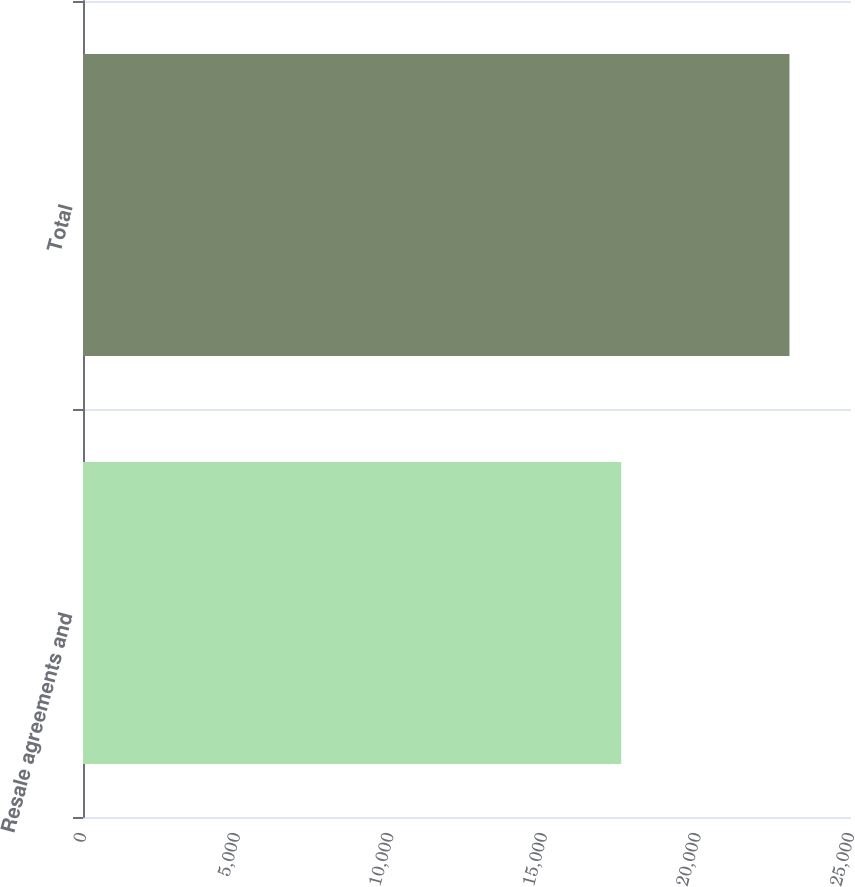Convert chart to OTSL. <chart><loc_0><loc_0><loc_500><loc_500><bar_chart><fcel>Resale agreements and<fcel>Total<nl><fcel>17521<fcel>22997<nl></chart> 